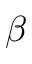Convert formula to latex. <formula><loc_0><loc_0><loc_500><loc_500>\beta</formula> 